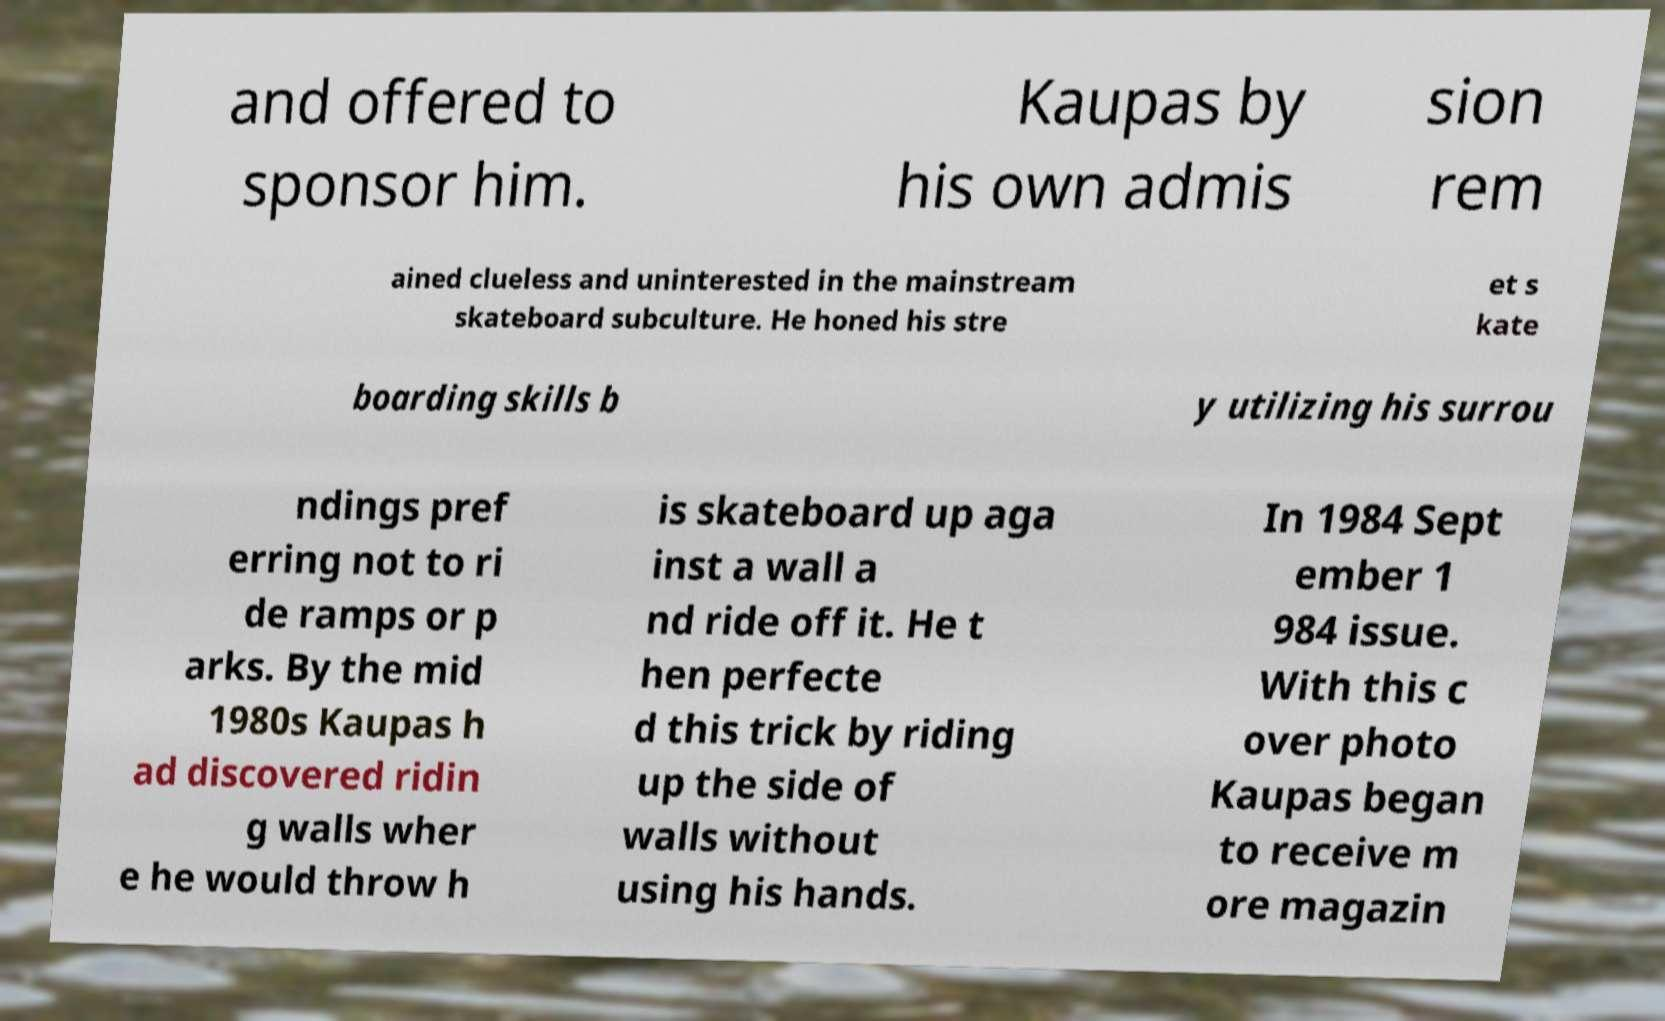There's text embedded in this image that I need extracted. Can you transcribe it verbatim? and offered to sponsor him. Kaupas by his own admis sion rem ained clueless and uninterested in the mainstream skateboard subculture. He honed his stre et s kate boarding skills b y utilizing his surrou ndings pref erring not to ri de ramps or p arks. By the mid 1980s Kaupas h ad discovered ridin g walls wher e he would throw h is skateboard up aga inst a wall a nd ride off it. He t hen perfecte d this trick by riding up the side of walls without using his hands. In 1984 Sept ember 1 984 issue. With this c over photo Kaupas began to receive m ore magazin 